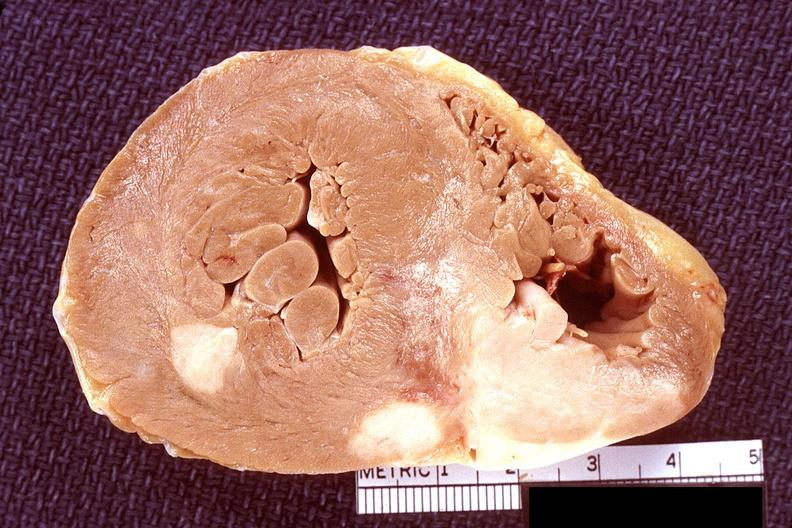what does this image show?
Answer the question using a single word or phrase. Heart 